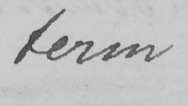Please provide the text content of this handwritten line. term 